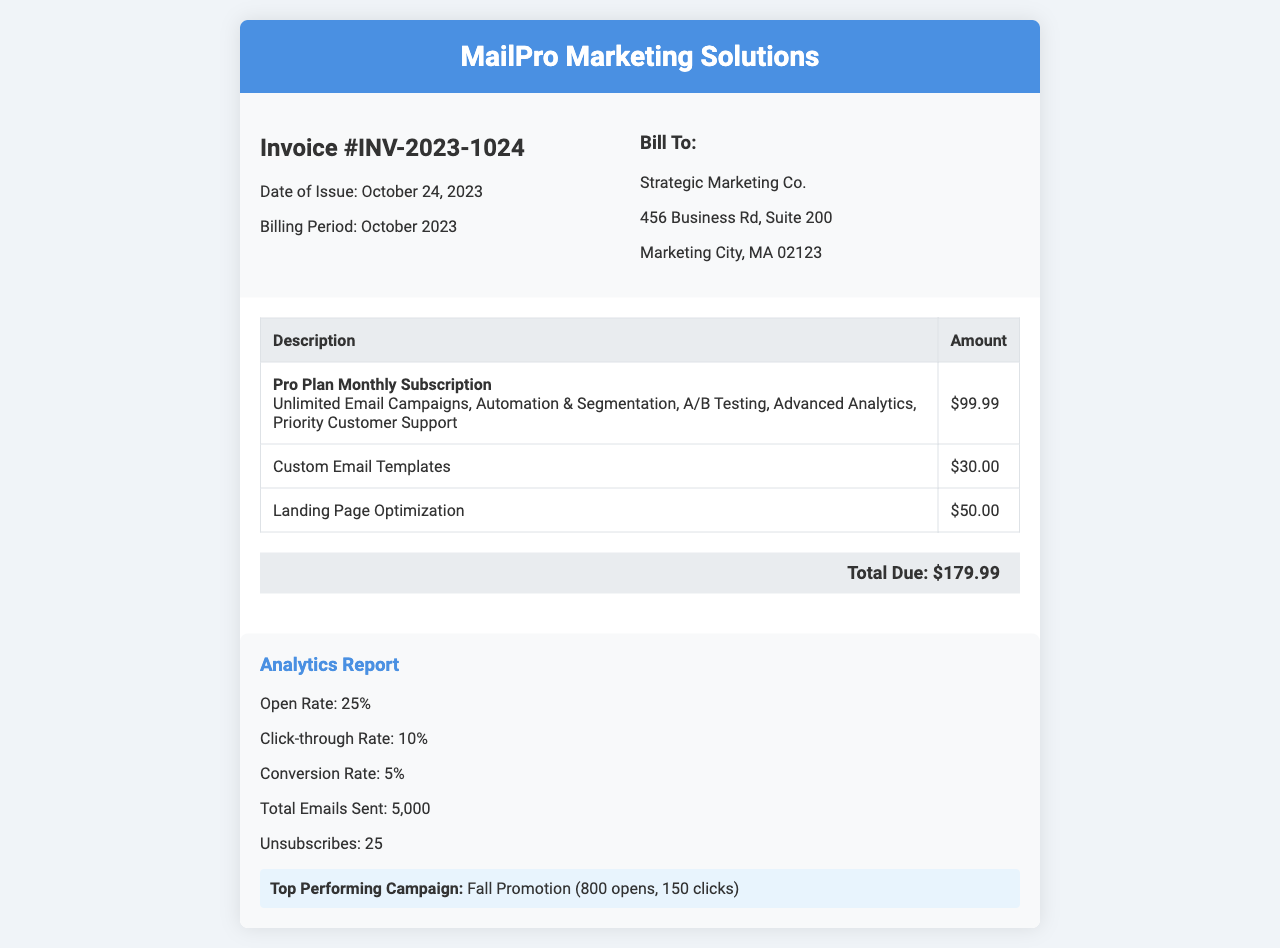What is the invoice number? The invoice number is listed at the top of the document as Invoice #INV-2023-1024.
Answer: INV-2023-1024 What is the billing period? The billing period for the invoice is specified as October 2023.
Answer: October 2023 What is the total due amount? The total amount due is calculated from all charges and is stated at the end of the invoice.
Answer: $179.99 How many emails were sent? The total number of emails sent is provided in the analytics section of the document.
Answer: 5,000 What is the open rate percentage? The open rate is provided in the analytics report as a specific metric.
Answer: 25% What features are included in the Pro Plan? The features included in the Pro Plan are explicitly listed in the description of the subscription.
Answer: Unlimited Email Campaigns, Automation & Segmentation, A/B Testing, Advanced Analytics, Priority Customer Support What was the top performing campaign? The name of the top performing campaign is mentioned in the performance highlight part of the analytics section.
Answer: Fall Promotion What is the click-through rate? The click-through rate is specified in the analytics report as a percentage.
Answer: 10% How much does the Custom Email Templates cost? The cost for Custom Email Templates is presented in the invoice table.
Answer: $30.00 